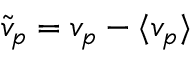<formula> <loc_0><loc_0><loc_500><loc_500>\tilde { v } _ { p } = v _ { p } - \langle v _ { p } \rangle</formula> 